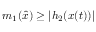Convert formula to latex. <formula><loc_0><loc_0><loc_500><loc_500>m _ { 1 } ( { \hat { x } } ) \geq | h _ { 2 } ( x ( t ) ) |</formula> 